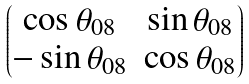Convert formula to latex. <formula><loc_0><loc_0><loc_500><loc_500>\begin{pmatrix} \cos \theta _ { 0 8 } & \sin \theta _ { 0 8 } \\ - \sin \theta _ { 0 8 } & \cos \theta _ { 0 8 } \end{pmatrix}</formula> 